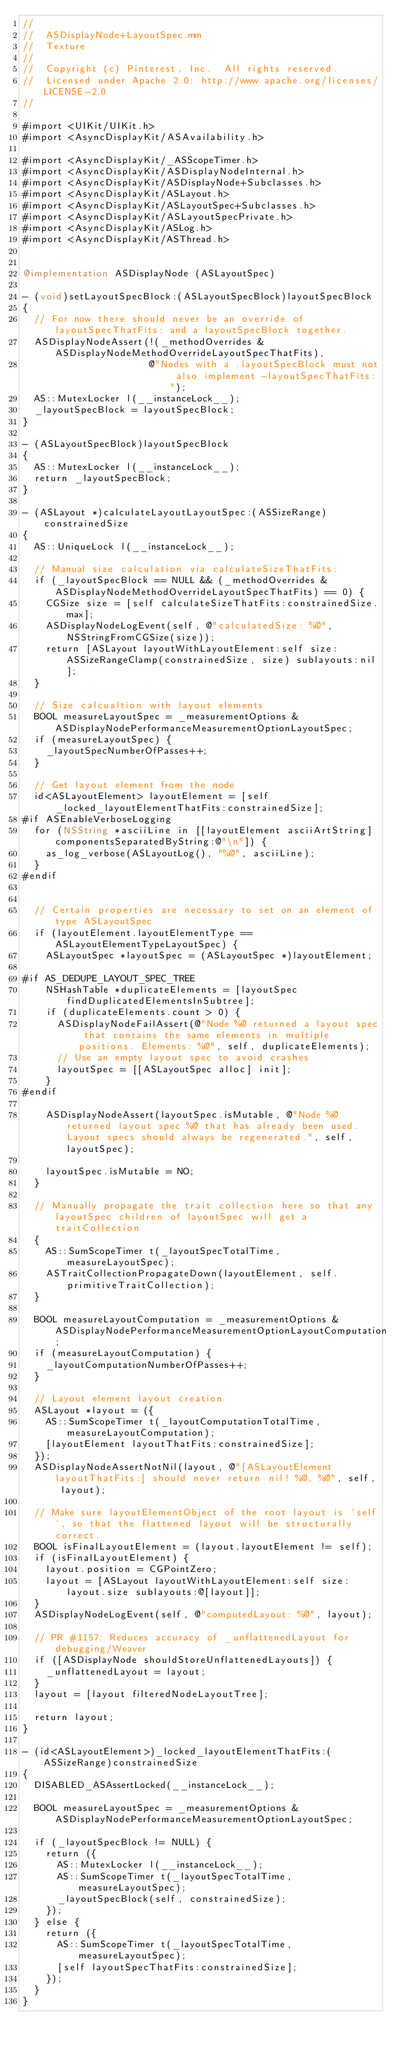Convert code to text. <code><loc_0><loc_0><loc_500><loc_500><_ObjectiveC_>//
//  ASDisplayNode+LayoutSpec.mm
//  Texture
//
//  Copyright (c) Pinterest, Inc.  All rights reserved.
//  Licensed under Apache 2.0: http://www.apache.org/licenses/LICENSE-2.0
//

#import <UIKit/UIKit.h>
#import <AsyncDisplayKit/ASAvailability.h>

#import <AsyncDisplayKit/_ASScopeTimer.h>
#import <AsyncDisplayKit/ASDisplayNodeInternal.h>
#import <AsyncDisplayKit/ASDisplayNode+Subclasses.h>
#import <AsyncDisplayKit/ASLayout.h>
#import <AsyncDisplayKit/ASLayoutSpec+Subclasses.h>
#import <AsyncDisplayKit/ASLayoutSpecPrivate.h>
#import <AsyncDisplayKit/ASLog.h>
#import <AsyncDisplayKit/ASThread.h>


@implementation ASDisplayNode (ASLayoutSpec)

- (void)setLayoutSpecBlock:(ASLayoutSpecBlock)layoutSpecBlock
{
  // For now there should never be an override of layoutSpecThatFits: and a layoutSpecBlock together.
  ASDisplayNodeAssert(!(_methodOverrides & ASDisplayNodeMethodOverrideLayoutSpecThatFits),
                      @"Nodes with a .layoutSpecBlock must not also implement -layoutSpecThatFits:");
  AS::MutexLocker l(__instanceLock__);
  _layoutSpecBlock = layoutSpecBlock;
}

- (ASLayoutSpecBlock)layoutSpecBlock
{
  AS::MutexLocker l(__instanceLock__);
  return _layoutSpecBlock;
}

- (ASLayout *)calculateLayoutLayoutSpec:(ASSizeRange)constrainedSize
{
  AS::UniqueLock l(__instanceLock__);

  // Manual size calculation via calculateSizeThatFits:
  if (_layoutSpecBlock == NULL && (_methodOverrides & ASDisplayNodeMethodOverrideLayoutSpecThatFits) == 0) {
    CGSize size = [self calculateSizeThatFits:constrainedSize.max];
    ASDisplayNodeLogEvent(self, @"calculatedSize: %@", NSStringFromCGSize(size));
    return [ASLayout layoutWithLayoutElement:self size:ASSizeRangeClamp(constrainedSize, size) sublayouts:nil];
  }

  // Size calcualtion with layout elements
  BOOL measureLayoutSpec = _measurementOptions & ASDisplayNodePerformanceMeasurementOptionLayoutSpec;
  if (measureLayoutSpec) {
    _layoutSpecNumberOfPasses++;
  }

  // Get layout element from the node
  id<ASLayoutElement> layoutElement = [self _locked_layoutElementThatFits:constrainedSize];
#if ASEnableVerboseLogging
  for (NSString *asciiLine in [[layoutElement asciiArtString] componentsSeparatedByString:@"\n"]) {
    as_log_verbose(ASLayoutLog(), "%@", asciiLine);
  }
#endif


  // Certain properties are necessary to set on an element of type ASLayoutSpec
  if (layoutElement.layoutElementType == ASLayoutElementTypeLayoutSpec) {
    ASLayoutSpec *layoutSpec = (ASLayoutSpec *)layoutElement;

#if AS_DEDUPE_LAYOUT_SPEC_TREE
    NSHashTable *duplicateElements = [layoutSpec findDuplicatedElementsInSubtree];
    if (duplicateElements.count > 0) {
      ASDisplayNodeFailAssert(@"Node %@ returned a layout spec that contains the same elements in multiple positions. Elements: %@", self, duplicateElements);
      // Use an empty layout spec to avoid crashes
      layoutSpec = [[ASLayoutSpec alloc] init];
    }
#endif

    ASDisplayNodeAssert(layoutSpec.isMutable, @"Node %@ returned layout spec %@ that has already been used. Layout specs should always be regenerated.", self, layoutSpec);

    layoutSpec.isMutable = NO;
  }

  // Manually propagate the trait collection here so that any layoutSpec children of layoutSpec will get a traitCollection
  {
    AS::SumScopeTimer t(_layoutSpecTotalTime, measureLayoutSpec);
    ASTraitCollectionPropagateDown(layoutElement, self.primitiveTraitCollection);
  }

  BOOL measureLayoutComputation = _measurementOptions & ASDisplayNodePerformanceMeasurementOptionLayoutComputation;
  if (measureLayoutComputation) {
    _layoutComputationNumberOfPasses++;
  }

  // Layout element layout creation
  ASLayout *layout = ({
    AS::SumScopeTimer t(_layoutComputationTotalTime, measureLayoutComputation);
    [layoutElement layoutThatFits:constrainedSize];
  });
  ASDisplayNodeAssertNotNil(layout, @"[ASLayoutElement layoutThatFits:] should never return nil! %@, %@", self, layout);

  // Make sure layoutElementObject of the root layout is `self`, so that the flattened layout will be structurally correct.
  BOOL isFinalLayoutElement = (layout.layoutElement != self);
  if (isFinalLayoutElement) {
    layout.position = CGPointZero;
    layout = [ASLayout layoutWithLayoutElement:self size:layout.size sublayouts:@[layout]];
  }
  ASDisplayNodeLogEvent(self, @"computedLayout: %@", layout);

  // PR #1157: Reduces accuracy of _unflattenedLayout for debugging/Weaver
  if ([ASDisplayNode shouldStoreUnflattenedLayouts]) {
    _unflattenedLayout = layout;
  }
  layout = [layout filteredNodeLayoutTree];

  return layout;
}

- (id<ASLayoutElement>)_locked_layoutElementThatFits:(ASSizeRange)constrainedSize
{
  DISABLED_ASAssertLocked(__instanceLock__);

  BOOL measureLayoutSpec = _measurementOptions & ASDisplayNodePerformanceMeasurementOptionLayoutSpec;

  if (_layoutSpecBlock != NULL) {
    return ({
      AS::MutexLocker l(__instanceLock__);
      AS::SumScopeTimer t(_layoutSpecTotalTime, measureLayoutSpec);
      _layoutSpecBlock(self, constrainedSize);
    });
  } else {
    return ({
      AS::SumScopeTimer t(_layoutSpecTotalTime, measureLayoutSpec);
      [self layoutSpecThatFits:constrainedSize];
    });
  }
}
</code> 